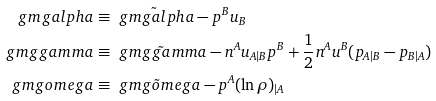<formula> <loc_0><loc_0><loc_500><loc_500>\ g m g a l p h a & \equiv \tilde { \ g m g a l p h a } - p ^ { B } u _ { B } \\ \ g m g g a m m a & \equiv \tilde { \ g m g g a m m a } - n ^ { A } u _ { A | B } p ^ { B } + \frac { 1 } { 2 } n ^ { A } u ^ { B } ( p _ { A | B } - p _ { B | A } ) \\ \ g m g o m e g a & \equiv \tilde { \ g m g o m e g a } - p ^ { A } ( \ln \rho ) _ { | A }</formula> 